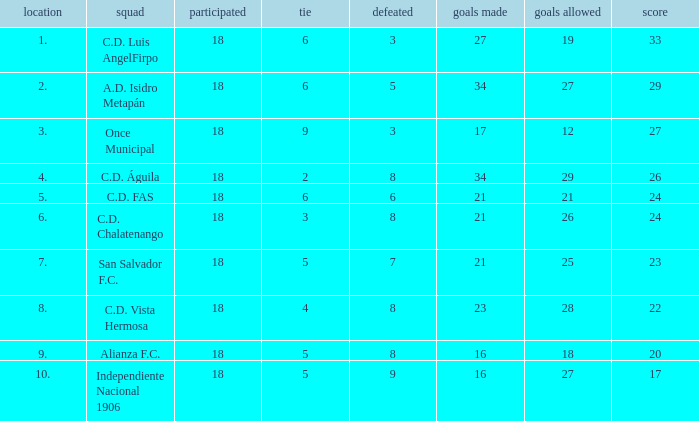For once municipal, what were the objectives achieved that had fewer than 27 points and higher than position 1? None. 